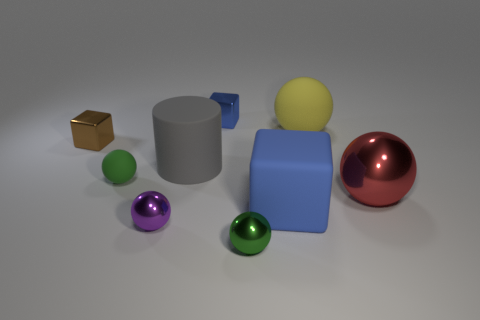The large shiny ball is what color? red 